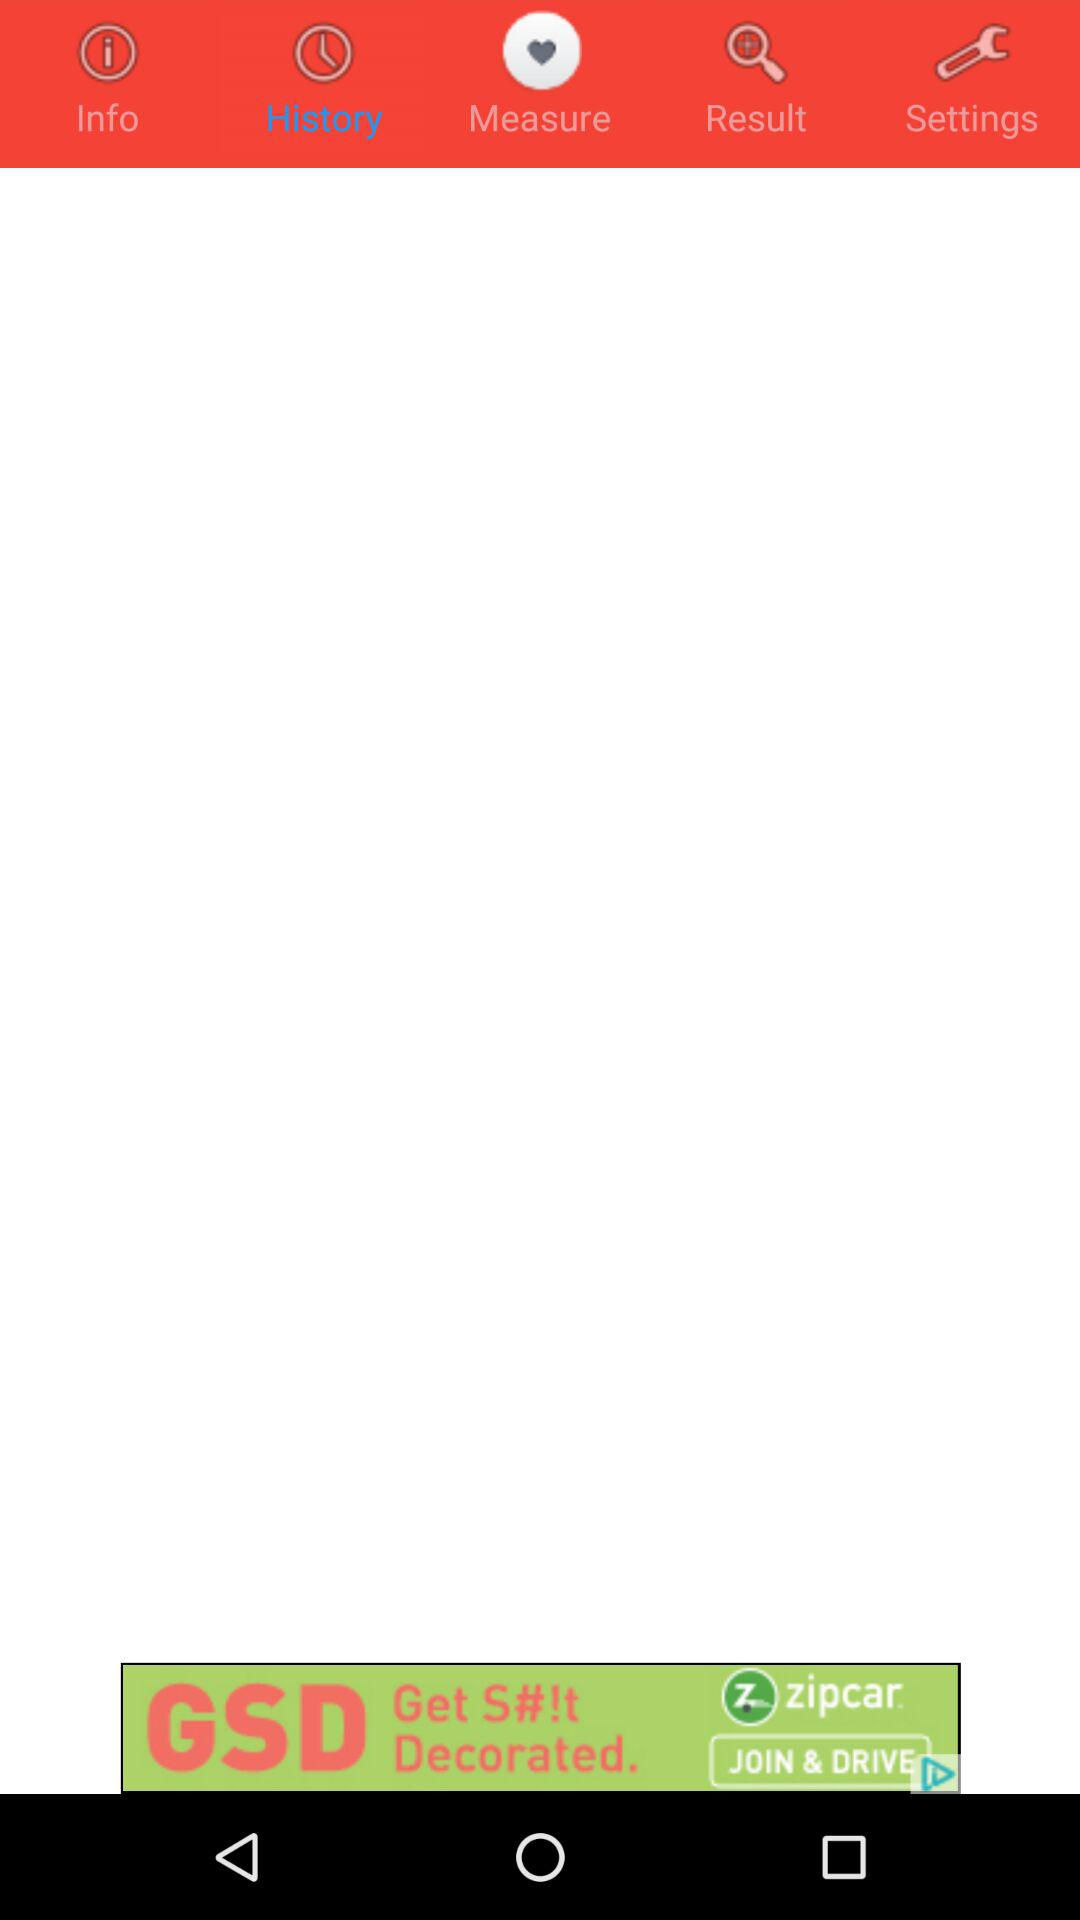How many reviews does the application have?
When the provided information is insufficient, respond with <no answer>. <no answer> 